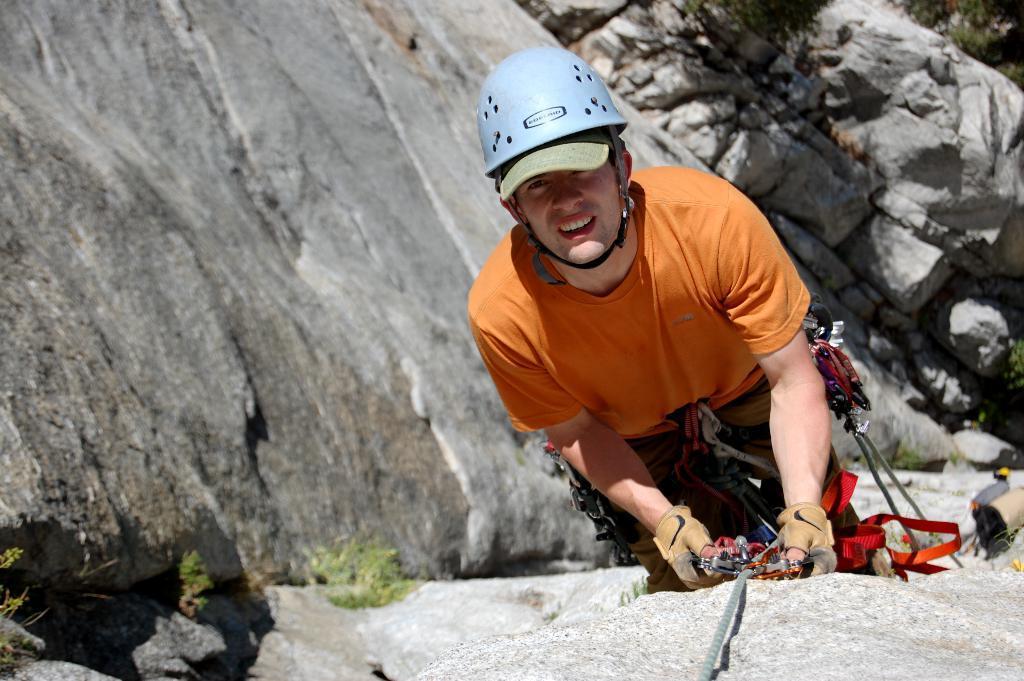Can you describe this image briefly? In this image we can see rocks. Also there is a person wearing helmet and gloves. He is holding an object with a rope. Also there are few plants. 